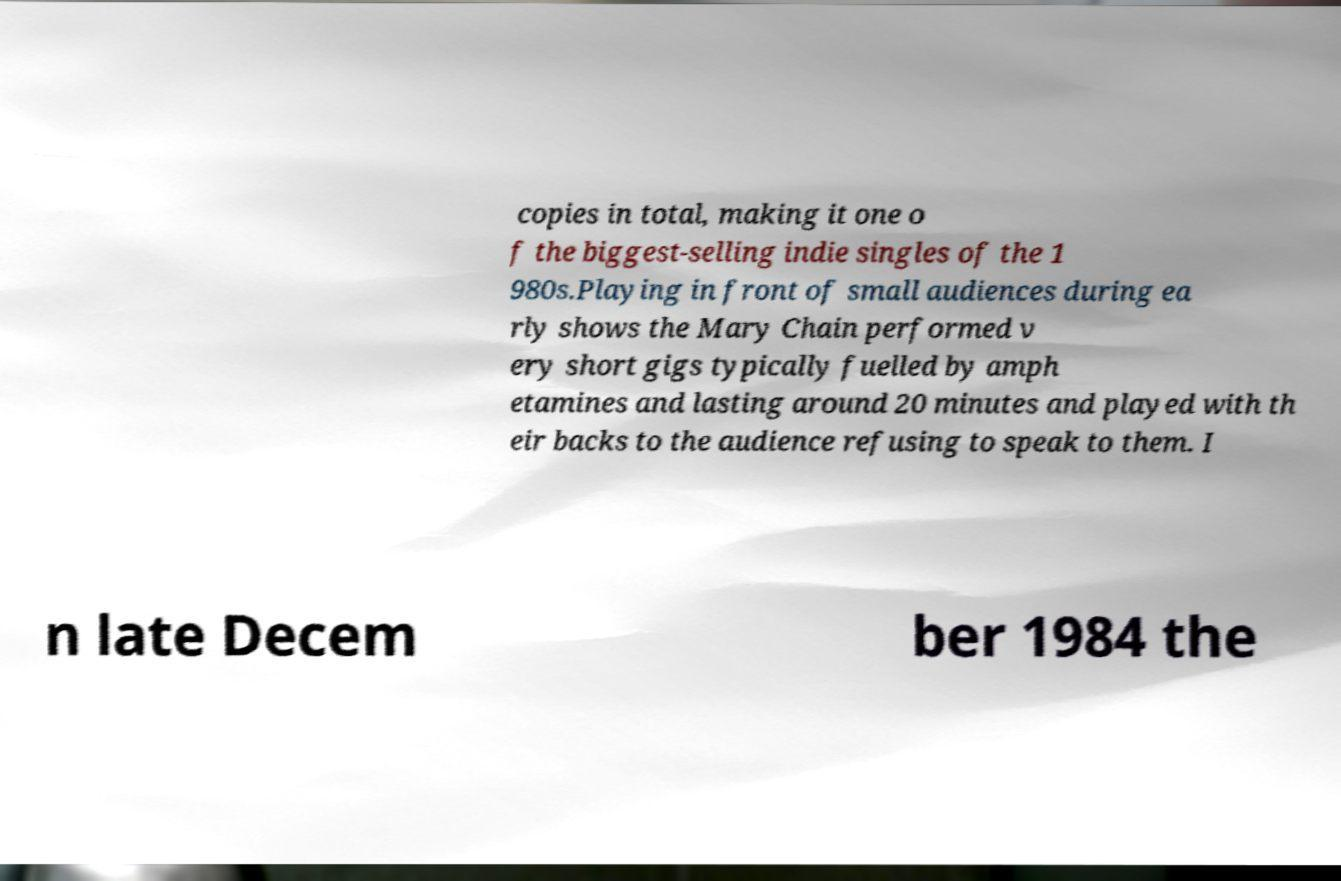What messages or text are displayed in this image? I need them in a readable, typed format. copies in total, making it one o f the biggest-selling indie singles of the 1 980s.Playing in front of small audiences during ea rly shows the Mary Chain performed v ery short gigs typically fuelled by amph etamines and lasting around 20 minutes and played with th eir backs to the audience refusing to speak to them. I n late Decem ber 1984 the 